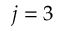Convert formula to latex. <formula><loc_0><loc_0><loc_500><loc_500>j = 3</formula> 